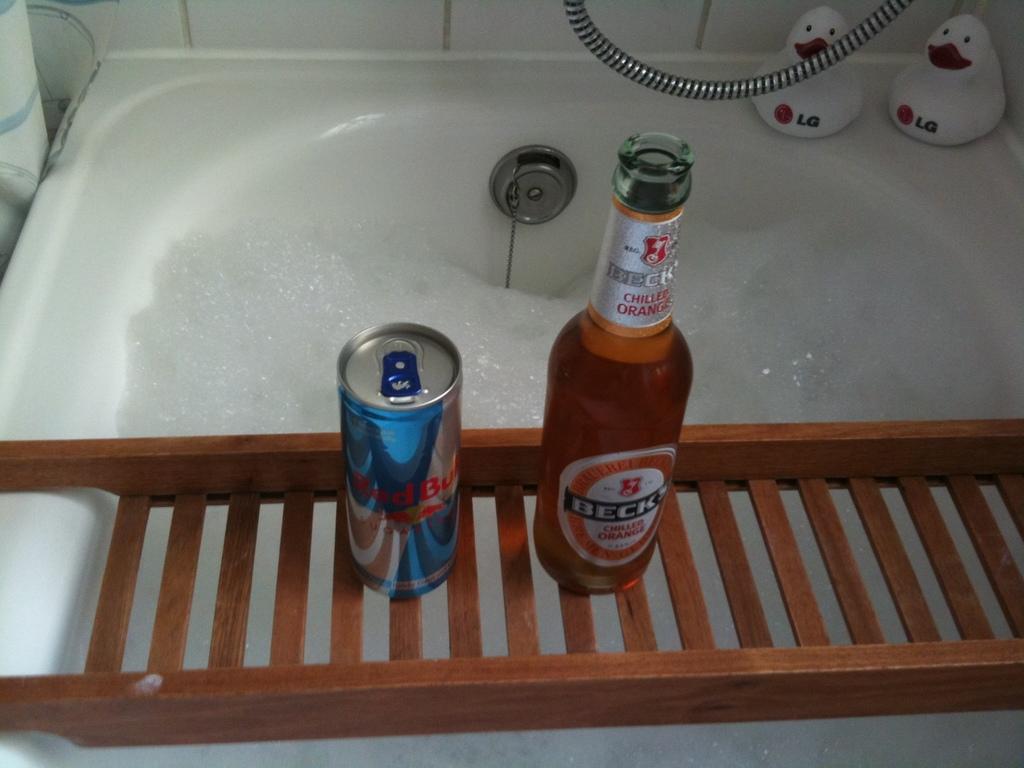In one or two sentences, can you explain what this image depicts? There is a glass bottle named beck kept on a wooden stand and beneath it there is a bathing tub filled with foam , behind that there are two white toys which are named as LG. 